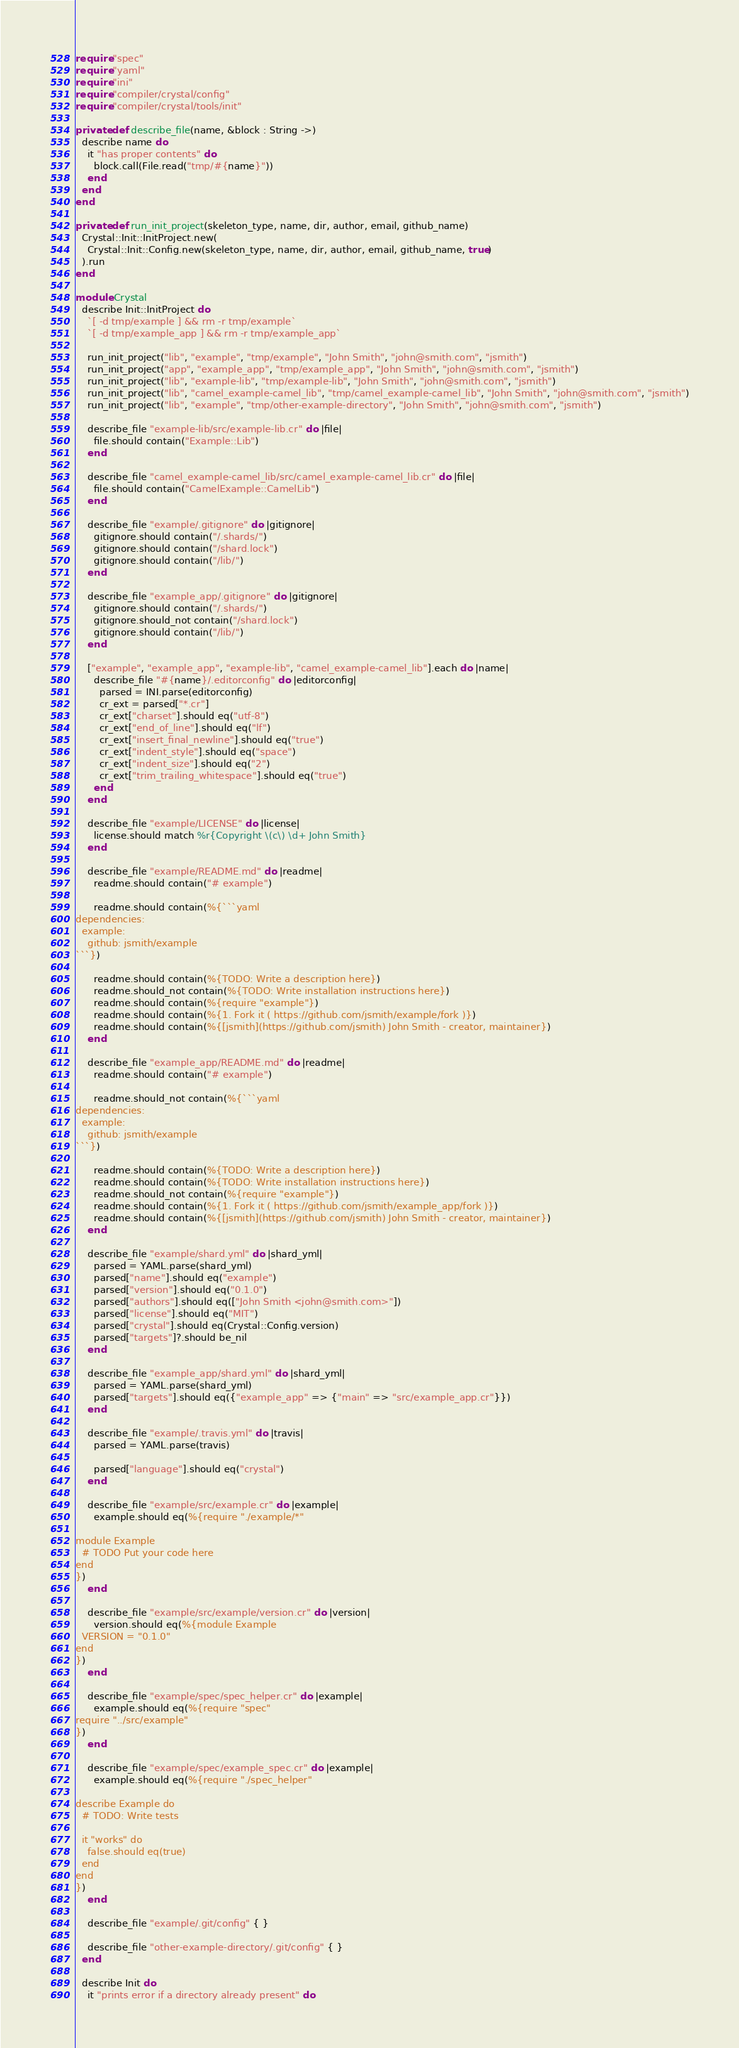Convert code to text. <code><loc_0><loc_0><loc_500><loc_500><_Crystal_>require "spec"
require "yaml"
require "ini"
require "compiler/crystal/config"
require "compiler/crystal/tools/init"

private def describe_file(name, &block : String ->)
  describe name do
    it "has proper contents" do
      block.call(File.read("tmp/#{name}"))
    end
  end
end

private def run_init_project(skeleton_type, name, dir, author, email, github_name)
  Crystal::Init::InitProject.new(
    Crystal::Init::Config.new(skeleton_type, name, dir, author, email, github_name, true)
  ).run
end

module Crystal
  describe Init::InitProject do
    `[ -d tmp/example ] && rm -r tmp/example`
    `[ -d tmp/example_app ] && rm -r tmp/example_app`

    run_init_project("lib", "example", "tmp/example", "John Smith", "john@smith.com", "jsmith")
    run_init_project("app", "example_app", "tmp/example_app", "John Smith", "john@smith.com", "jsmith")
    run_init_project("lib", "example-lib", "tmp/example-lib", "John Smith", "john@smith.com", "jsmith")
    run_init_project("lib", "camel_example-camel_lib", "tmp/camel_example-camel_lib", "John Smith", "john@smith.com", "jsmith")
    run_init_project("lib", "example", "tmp/other-example-directory", "John Smith", "john@smith.com", "jsmith")

    describe_file "example-lib/src/example-lib.cr" do |file|
      file.should contain("Example::Lib")
    end

    describe_file "camel_example-camel_lib/src/camel_example-camel_lib.cr" do |file|
      file.should contain("CamelExample::CamelLib")
    end

    describe_file "example/.gitignore" do |gitignore|
      gitignore.should contain("/.shards/")
      gitignore.should contain("/shard.lock")
      gitignore.should contain("/lib/")
    end

    describe_file "example_app/.gitignore" do |gitignore|
      gitignore.should contain("/.shards/")
      gitignore.should_not contain("/shard.lock")
      gitignore.should contain("/lib/")
    end

    ["example", "example_app", "example-lib", "camel_example-camel_lib"].each do |name|
      describe_file "#{name}/.editorconfig" do |editorconfig|
        parsed = INI.parse(editorconfig)
        cr_ext = parsed["*.cr"]
        cr_ext["charset"].should eq("utf-8")
        cr_ext["end_of_line"].should eq("lf")
        cr_ext["insert_final_newline"].should eq("true")
        cr_ext["indent_style"].should eq("space")
        cr_ext["indent_size"].should eq("2")
        cr_ext["trim_trailing_whitespace"].should eq("true")
      end
    end

    describe_file "example/LICENSE" do |license|
      license.should match %r{Copyright \(c\) \d+ John Smith}
    end

    describe_file "example/README.md" do |readme|
      readme.should contain("# example")

      readme.should contain(%{```yaml
dependencies:
  example:
    github: jsmith/example
```})

      readme.should contain(%{TODO: Write a description here})
      readme.should_not contain(%{TODO: Write installation instructions here})
      readme.should contain(%{require "example"})
      readme.should contain(%{1. Fork it ( https://github.com/jsmith/example/fork )})
      readme.should contain(%{[jsmith](https://github.com/jsmith) John Smith - creator, maintainer})
    end

    describe_file "example_app/README.md" do |readme|
      readme.should contain("# example")

      readme.should_not contain(%{```yaml
dependencies:
  example:
    github: jsmith/example
```})

      readme.should contain(%{TODO: Write a description here})
      readme.should contain(%{TODO: Write installation instructions here})
      readme.should_not contain(%{require "example"})
      readme.should contain(%{1. Fork it ( https://github.com/jsmith/example_app/fork )})
      readme.should contain(%{[jsmith](https://github.com/jsmith) John Smith - creator, maintainer})
    end

    describe_file "example/shard.yml" do |shard_yml|
      parsed = YAML.parse(shard_yml)
      parsed["name"].should eq("example")
      parsed["version"].should eq("0.1.0")
      parsed["authors"].should eq(["John Smith <john@smith.com>"])
      parsed["license"].should eq("MIT")
      parsed["crystal"].should eq(Crystal::Config.version)
      parsed["targets"]?.should be_nil
    end

    describe_file "example_app/shard.yml" do |shard_yml|
      parsed = YAML.parse(shard_yml)
      parsed["targets"].should eq({"example_app" => {"main" => "src/example_app.cr"}})
    end

    describe_file "example/.travis.yml" do |travis|
      parsed = YAML.parse(travis)

      parsed["language"].should eq("crystal")
    end

    describe_file "example/src/example.cr" do |example|
      example.should eq(%{require "./example/*"

module Example
  # TODO Put your code here
end
})
    end

    describe_file "example/src/example/version.cr" do |version|
      version.should eq(%{module Example
  VERSION = "0.1.0"
end
})
    end

    describe_file "example/spec/spec_helper.cr" do |example|
      example.should eq(%{require "spec"
require "../src/example"
})
    end

    describe_file "example/spec/example_spec.cr" do |example|
      example.should eq(%{require "./spec_helper"

describe Example do
  # TODO: Write tests

  it "works" do
    false.should eq(true)
  end
end
})
    end

    describe_file "example/.git/config" { }

    describe_file "other-example-directory/.git/config" { }
  end

  describe Init do
    it "prints error if a directory already present" do</code> 